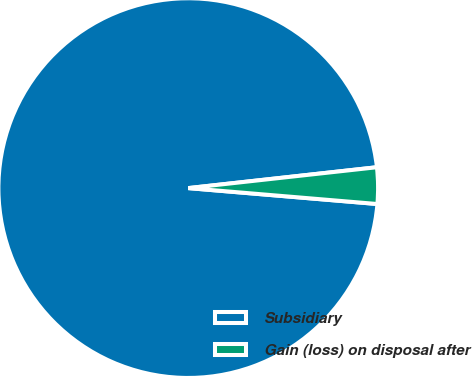<chart> <loc_0><loc_0><loc_500><loc_500><pie_chart><fcel>Subsidiary<fcel>Gain (loss) on disposal after<nl><fcel>96.91%<fcel>3.09%<nl></chart> 